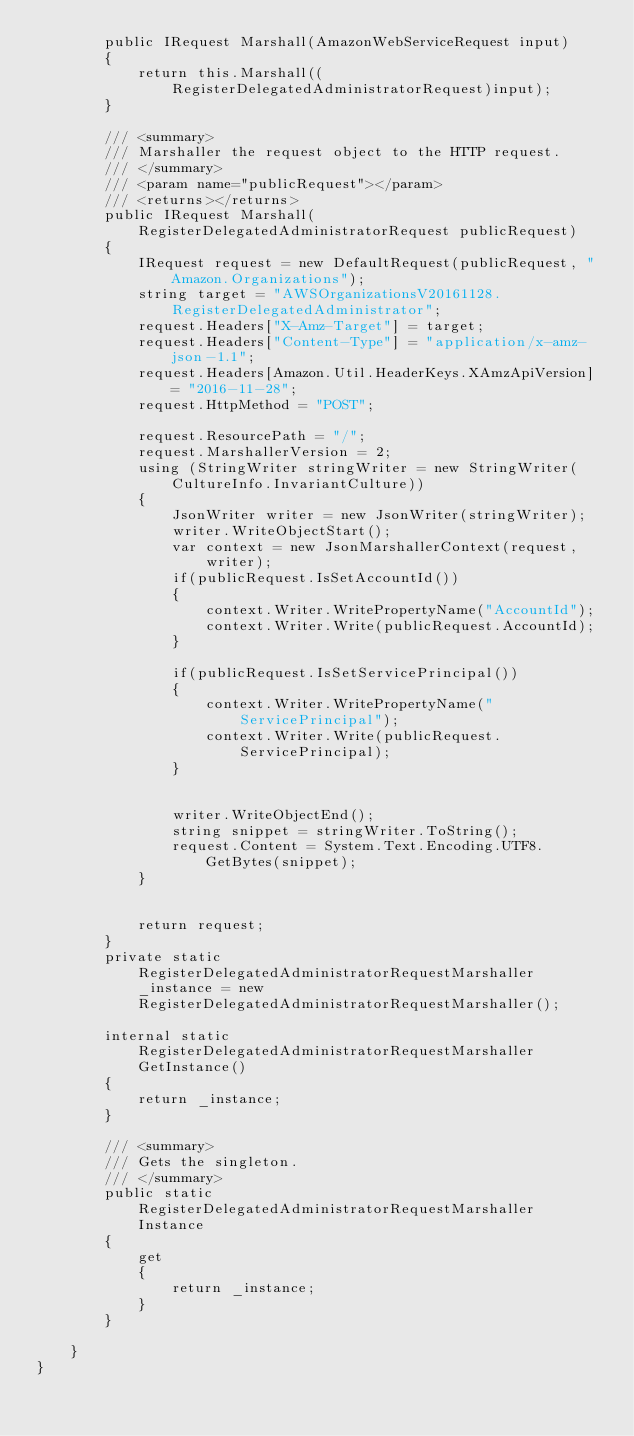Convert code to text. <code><loc_0><loc_0><loc_500><loc_500><_C#_>        public IRequest Marshall(AmazonWebServiceRequest input)
        {
            return this.Marshall((RegisterDelegatedAdministratorRequest)input);
        }

        /// <summary>
        /// Marshaller the request object to the HTTP request.
        /// </summary>  
        /// <param name="publicRequest"></param>
        /// <returns></returns>
        public IRequest Marshall(RegisterDelegatedAdministratorRequest publicRequest)
        {
            IRequest request = new DefaultRequest(publicRequest, "Amazon.Organizations");
            string target = "AWSOrganizationsV20161128.RegisterDelegatedAdministrator";
            request.Headers["X-Amz-Target"] = target;
            request.Headers["Content-Type"] = "application/x-amz-json-1.1";
            request.Headers[Amazon.Util.HeaderKeys.XAmzApiVersion] = "2016-11-28";            
            request.HttpMethod = "POST";

            request.ResourcePath = "/";
            request.MarshallerVersion = 2;
            using (StringWriter stringWriter = new StringWriter(CultureInfo.InvariantCulture))
            {
                JsonWriter writer = new JsonWriter(stringWriter);
                writer.WriteObjectStart();
                var context = new JsonMarshallerContext(request, writer);
                if(publicRequest.IsSetAccountId())
                {
                    context.Writer.WritePropertyName("AccountId");
                    context.Writer.Write(publicRequest.AccountId);
                }

                if(publicRequest.IsSetServicePrincipal())
                {
                    context.Writer.WritePropertyName("ServicePrincipal");
                    context.Writer.Write(publicRequest.ServicePrincipal);
                }

        
                writer.WriteObjectEnd();
                string snippet = stringWriter.ToString();
                request.Content = System.Text.Encoding.UTF8.GetBytes(snippet);
            }


            return request;
        }
        private static RegisterDelegatedAdministratorRequestMarshaller _instance = new RegisterDelegatedAdministratorRequestMarshaller();        

        internal static RegisterDelegatedAdministratorRequestMarshaller GetInstance()
        {
            return _instance;
        }

        /// <summary>
        /// Gets the singleton.
        /// </summary>  
        public static RegisterDelegatedAdministratorRequestMarshaller Instance
        {
            get
            {
                return _instance;
            }
        }

    }
}</code> 